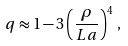<formula> <loc_0><loc_0><loc_500><loc_500>q \approx 1 - 3 \left ( \frac { \rho } { L a } \right ) ^ { 4 } \, ,</formula> 